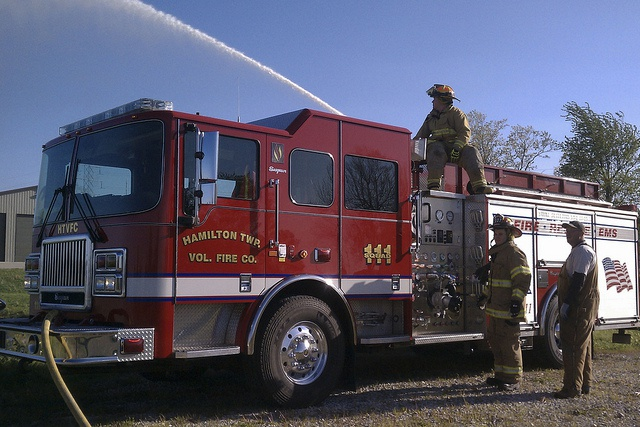Describe the objects in this image and their specific colors. I can see truck in gray, black, maroon, and navy tones, people in gray, black, and darkgreen tones, people in gray, black, and maroon tones, and people in gray, black, darkgreen, and darkgray tones in this image. 